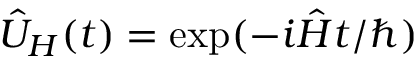<formula> <loc_0><loc_0><loc_500><loc_500>\hat { U } _ { H } ( t ) = \exp ( - i \hat { H } t / \hbar { ) }</formula> 